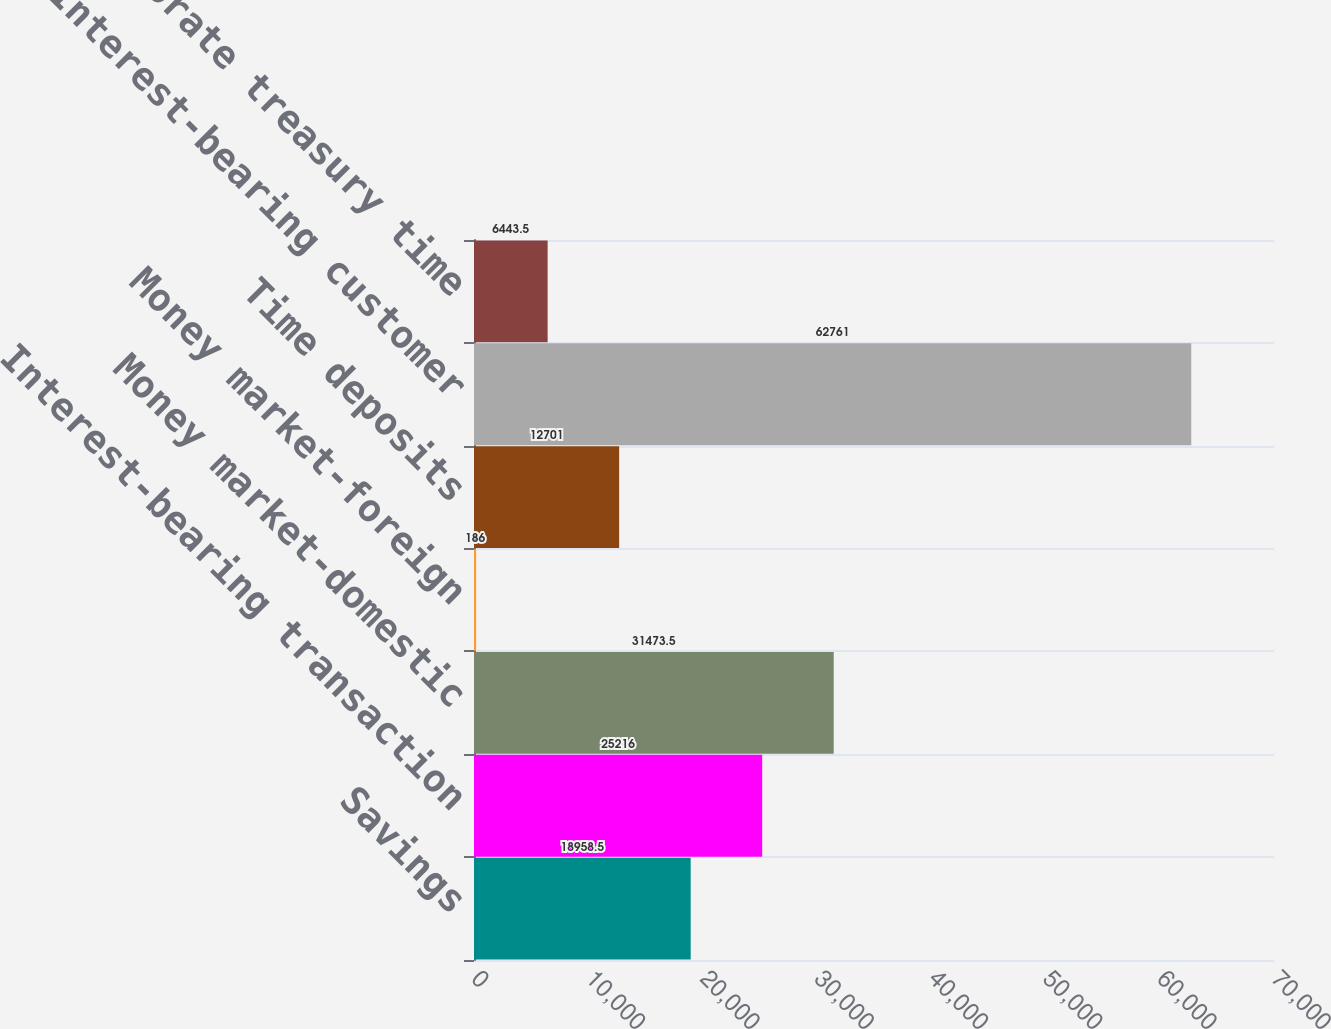Convert chart to OTSL. <chart><loc_0><loc_0><loc_500><loc_500><bar_chart><fcel>Savings<fcel>Interest-bearing transaction<fcel>Money market-domestic<fcel>Money market-foreign<fcel>Time deposits<fcel>Interest-bearing customer<fcel>Corporate treasury time<nl><fcel>18958.5<fcel>25216<fcel>31473.5<fcel>186<fcel>12701<fcel>62761<fcel>6443.5<nl></chart> 